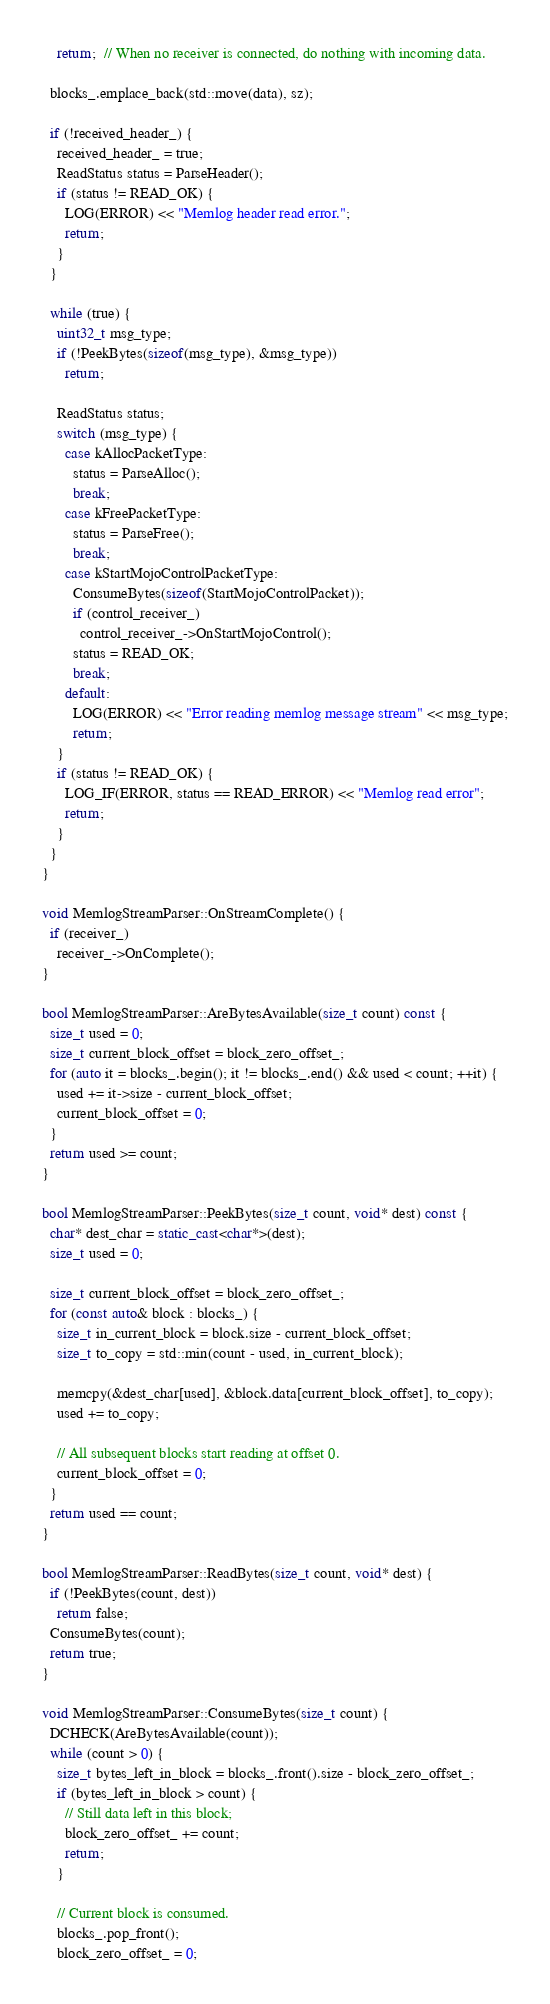Convert code to text. <code><loc_0><loc_0><loc_500><loc_500><_C++_>    return;  // When no receiver is connected, do nothing with incoming data.

  blocks_.emplace_back(std::move(data), sz);

  if (!received_header_) {
    received_header_ = true;
    ReadStatus status = ParseHeader();
    if (status != READ_OK) {
      LOG(ERROR) << "Memlog header read error.";
      return;
    }
  }

  while (true) {
    uint32_t msg_type;
    if (!PeekBytes(sizeof(msg_type), &msg_type))
      return;

    ReadStatus status;
    switch (msg_type) {
      case kAllocPacketType:
        status = ParseAlloc();
        break;
      case kFreePacketType:
        status = ParseFree();
        break;
      case kStartMojoControlPacketType:
        ConsumeBytes(sizeof(StartMojoControlPacket));
        if (control_receiver_)
          control_receiver_->OnStartMojoControl();
        status = READ_OK;
        break;
      default:
        LOG(ERROR) << "Error reading memlog message stream" << msg_type;
        return;
    }
    if (status != READ_OK) {
      LOG_IF(ERROR, status == READ_ERROR) << "Memlog read error";
      return;
    }
  }
}

void MemlogStreamParser::OnStreamComplete() {
  if (receiver_)
    receiver_->OnComplete();
}

bool MemlogStreamParser::AreBytesAvailable(size_t count) const {
  size_t used = 0;
  size_t current_block_offset = block_zero_offset_;
  for (auto it = blocks_.begin(); it != blocks_.end() && used < count; ++it) {
    used += it->size - current_block_offset;
    current_block_offset = 0;
  }
  return used >= count;
}

bool MemlogStreamParser::PeekBytes(size_t count, void* dest) const {
  char* dest_char = static_cast<char*>(dest);
  size_t used = 0;

  size_t current_block_offset = block_zero_offset_;
  for (const auto& block : blocks_) {
    size_t in_current_block = block.size - current_block_offset;
    size_t to_copy = std::min(count - used, in_current_block);

    memcpy(&dest_char[used], &block.data[current_block_offset], to_copy);
    used += to_copy;

    // All subsequent blocks start reading at offset 0.
    current_block_offset = 0;
  }
  return used == count;
}

bool MemlogStreamParser::ReadBytes(size_t count, void* dest) {
  if (!PeekBytes(count, dest))
    return false;
  ConsumeBytes(count);
  return true;
}

void MemlogStreamParser::ConsumeBytes(size_t count) {
  DCHECK(AreBytesAvailable(count));
  while (count > 0) {
    size_t bytes_left_in_block = blocks_.front().size - block_zero_offset_;
    if (bytes_left_in_block > count) {
      // Still data left in this block;
      block_zero_offset_ += count;
      return;
    }

    // Current block is consumed.
    blocks_.pop_front();
    block_zero_offset_ = 0;</code> 